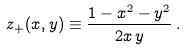Convert formula to latex. <formula><loc_0><loc_0><loc_500><loc_500>z _ { + } ( x , y ) \equiv \frac { 1 - x ^ { 2 } - y ^ { 2 } } { 2 x \, y } \, .</formula> 